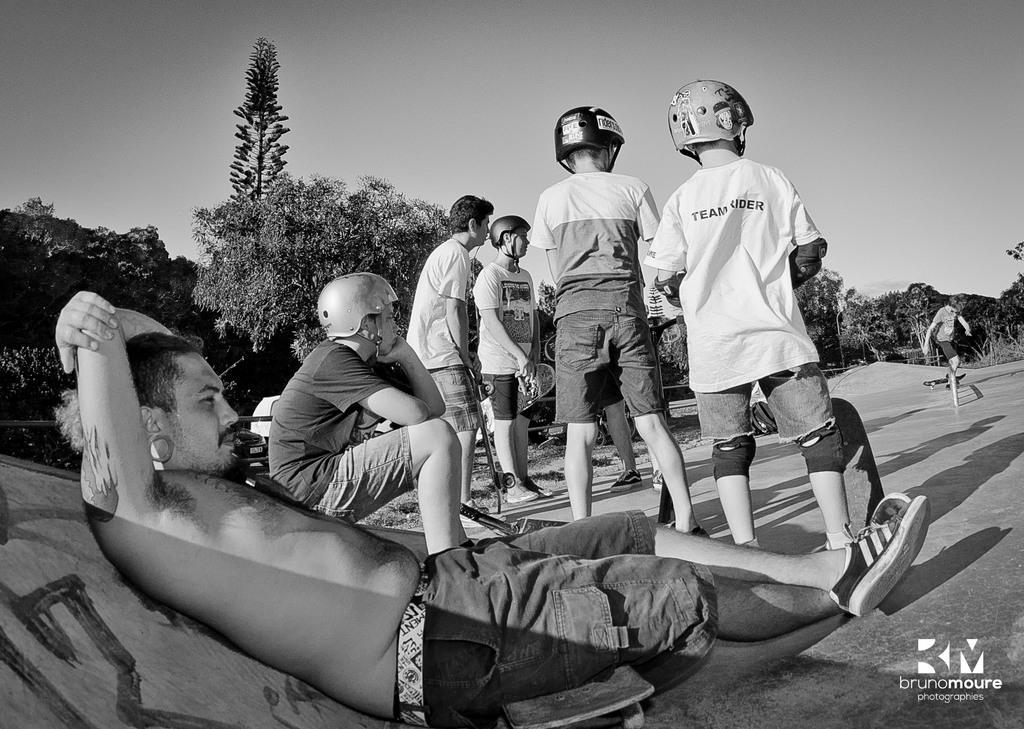Please provide a concise description of this image. This is a black and white image. In this image we can see persons standing on the floor. At the bottom of the image we can see person sitting on the skateboard. In The background we can see trees and sky. 